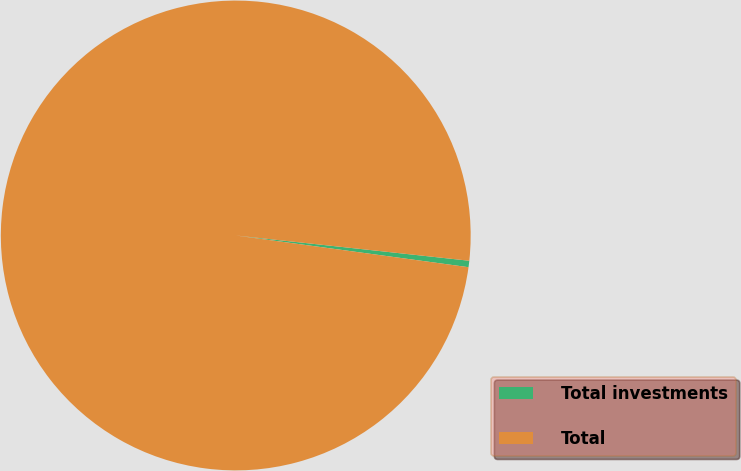Convert chart. <chart><loc_0><loc_0><loc_500><loc_500><pie_chart><fcel>Total investments<fcel>Total<nl><fcel>0.44%<fcel>99.56%<nl></chart> 